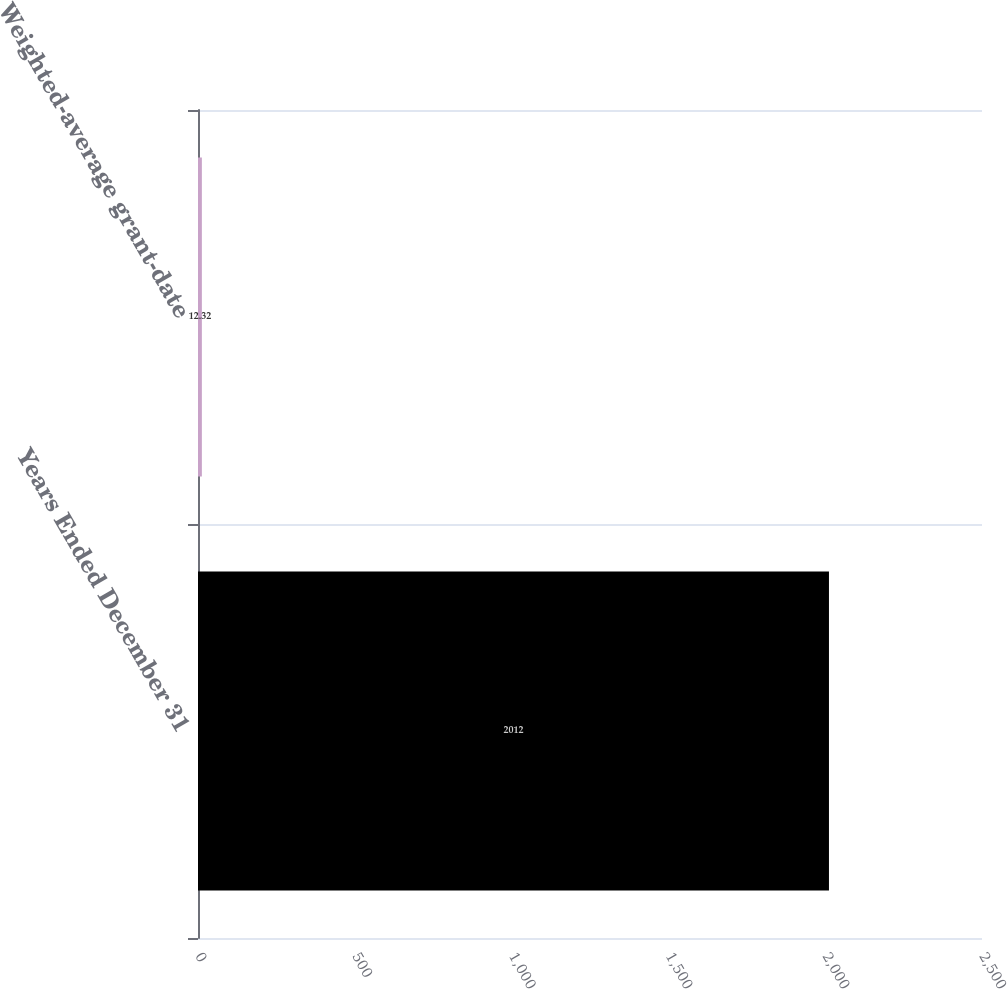Convert chart to OTSL. <chart><loc_0><loc_0><loc_500><loc_500><bar_chart><fcel>Years Ended December 31<fcel>Weighted-average grant-date<nl><fcel>2012<fcel>12.32<nl></chart> 